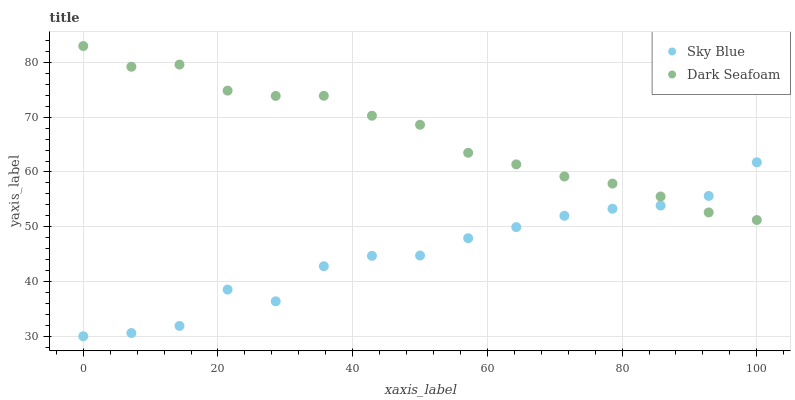Does Sky Blue have the minimum area under the curve?
Answer yes or no. Yes. Does Dark Seafoam have the maximum area under the curve?
Answer yes or no. Yes. Does Dark Seafoam have the minimum area under the curve?
Answer yes or no. No. Is Dark Seafoam the smoothest?
Answer yes or no. Yes. Is Sky Blue the roughest?
Answer yes or no. Yes. Is Dark Seafoam the roughest?
Answer yes or no. No. Does Sky Blue have the lowest value?
Answer yes or no. Yes. Does Dark Seafoam have the lowest value?
Answer yes or no. No. Does Dark Seafoam have the highest value?
Answer yes or no. Yes. Does Dark Seafoam intersect Sky Blue?
Answer yes or no. Yes. Is Dark Seafoam less than Sky Blue?
Answer yes or no. No. Is Dark Seafoam greater than Sky Blue?
Answer yes or no. No. 